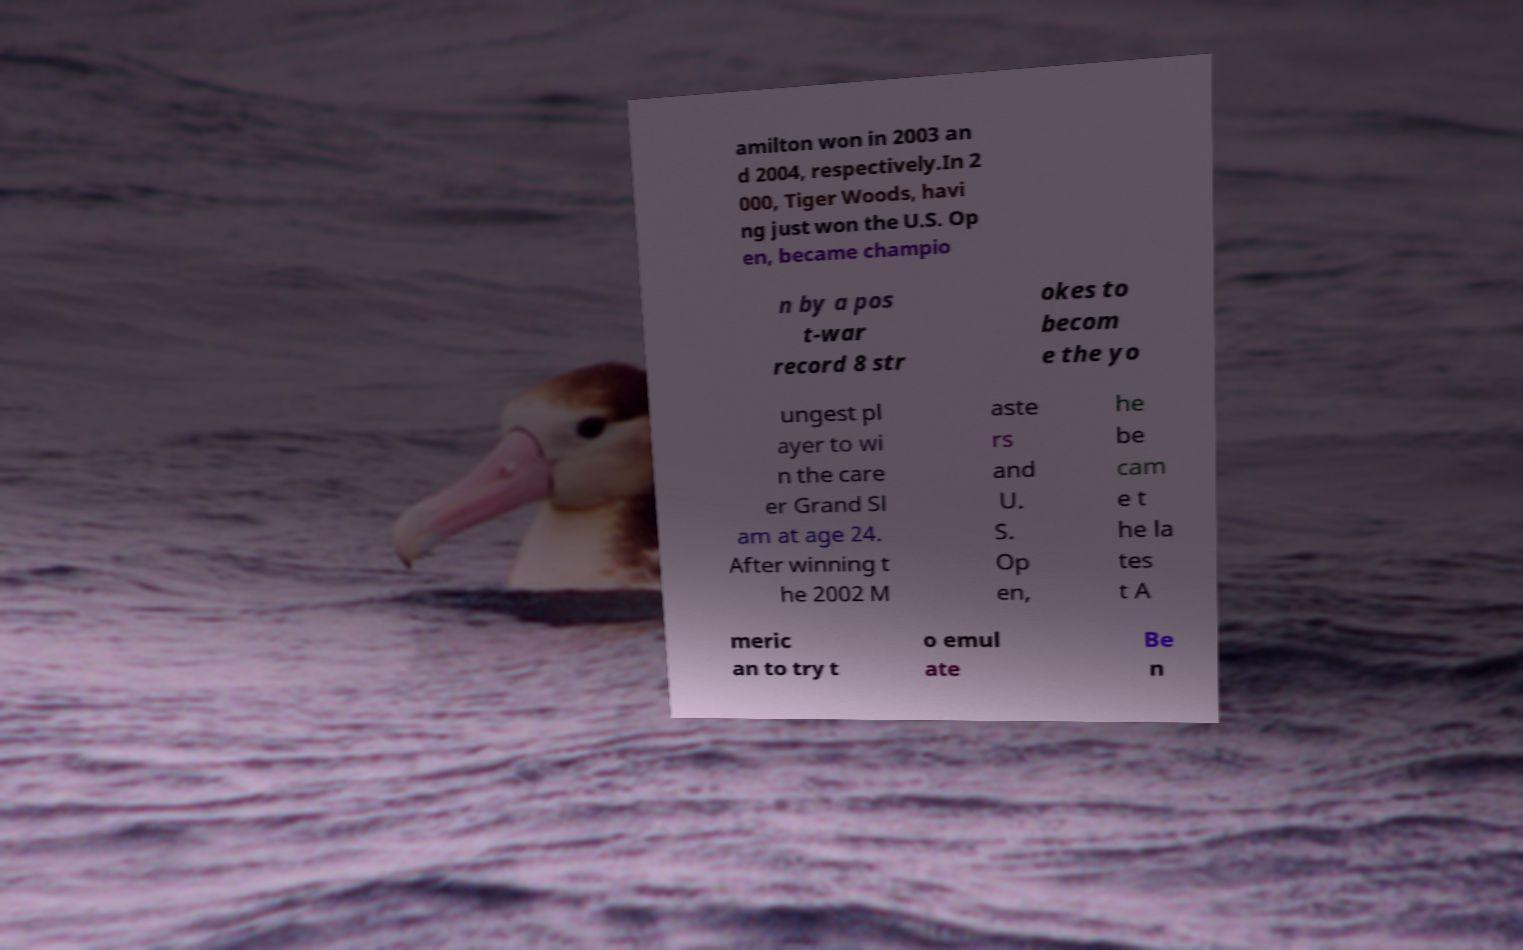Could you extract and type out the text from this image? amilton won in 2003 an d 2004, respectively.In 2 000, Tiger Woods, havi ng just won the U.S. Op en, became champio n by a pos t-war record 8 str okes to becom e the yo ungest pl ayer to wi n the care er Grand Sl am at age 24. After winning t he 2002 M aste rs and U. S. Op en, he be cam e t he la tes t A meric an to try t o emul ate Be n 